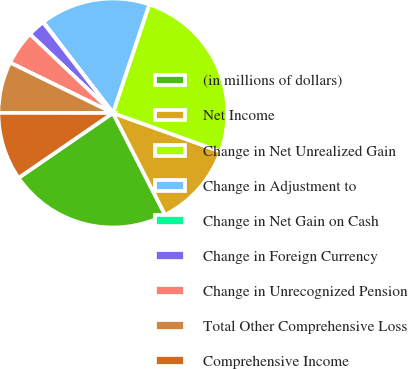Convert chart. <chart><loc_0><loc_0><loc_500><loc_500><pie_chart><fcel>(in millions of dollars)<fcel>Net Income<fcel>Change in Net Unrealized Gain<fcel>Change in Adjustment to<fcel>Change in Net Gain on Cash<fcel>Change in Foreign Currency<fcel>Change in Unrecognized Pension<fcel>Total Other Comprehensive Loss<fcel>Comprehensive Income<nl><fcel>22.94%<fcel>12.0%<fcel>25.33%<fcel>15.54%<fcel>0.06%<fcel>2.45%<fcel>4.84%<fcel>7.23%<fcel>9.61%<nl></chart> 